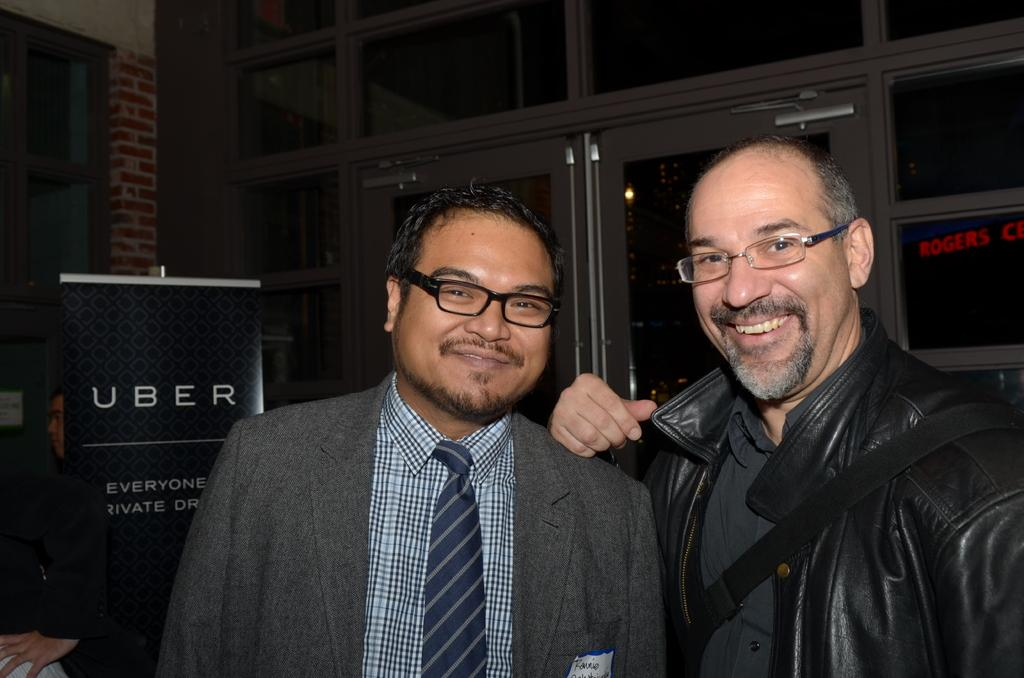How many men are in the image? There are two men in the center of the image. What can be seen in the background of the image? There are windows in the background of the image. Where is the third man located in the image? There is a man on the left side of the image. What is present on the left side of the image besides the man? There is a poster on the left side of the image. How many apples are being held by the crow in the image? There is no crow or apples present in the image. What type of pail is being used by the men in the image? There is no pail visible in the image. 